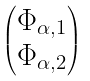Convert formula to latex. <formula><loc_0><loc_0><loc_500><loc_500>\begin{pmatrix} \Phi _ { \alpha , 1 } \\ \Phi _ { \alpha , 2 } \end{pmatrix}</formula> 